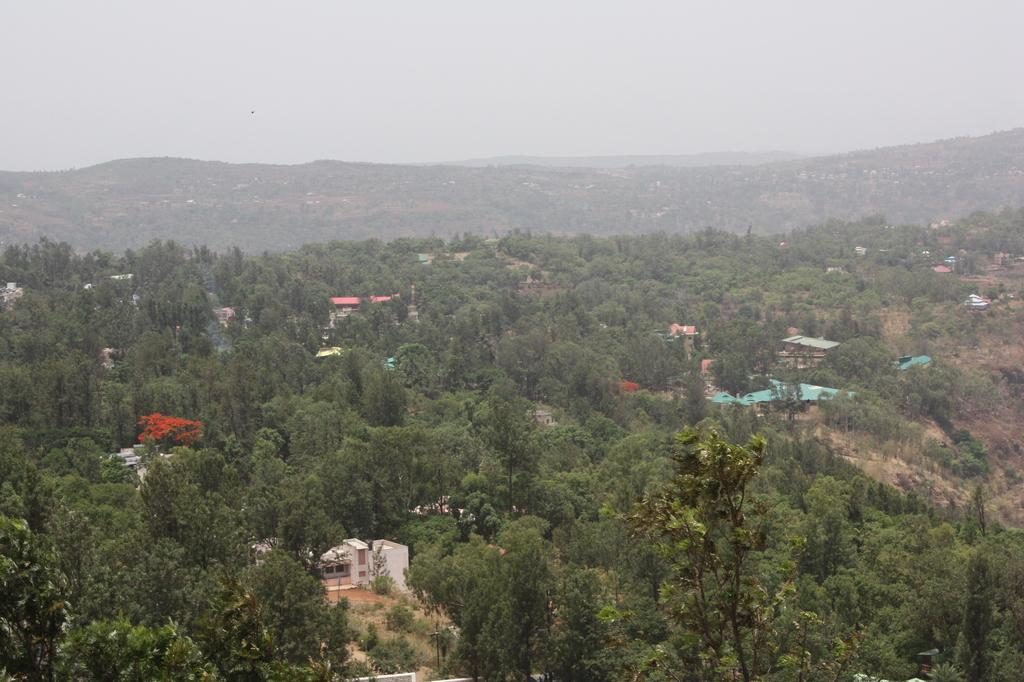What type of view is depicted in the image? The image might be an aerial view of a city. What type of structures can be seen in the image? There are houses in the image. What objects are present in the sky in the image? There are satellites in the image. What type of vegetation can be seen in the image? There are trees and plants in the image. What type of natural landforms can be seen in the image? There are mountains in the image. What type of geological features can be seen in the image? There are rocks in the image. What is visible at the top of the image? The sky is visible at the top of the image. What type of quartz can be seen in the image? There is no quartz present in the image. How many sheep can be seen grazing in the image? There are no sheep present in the image. 